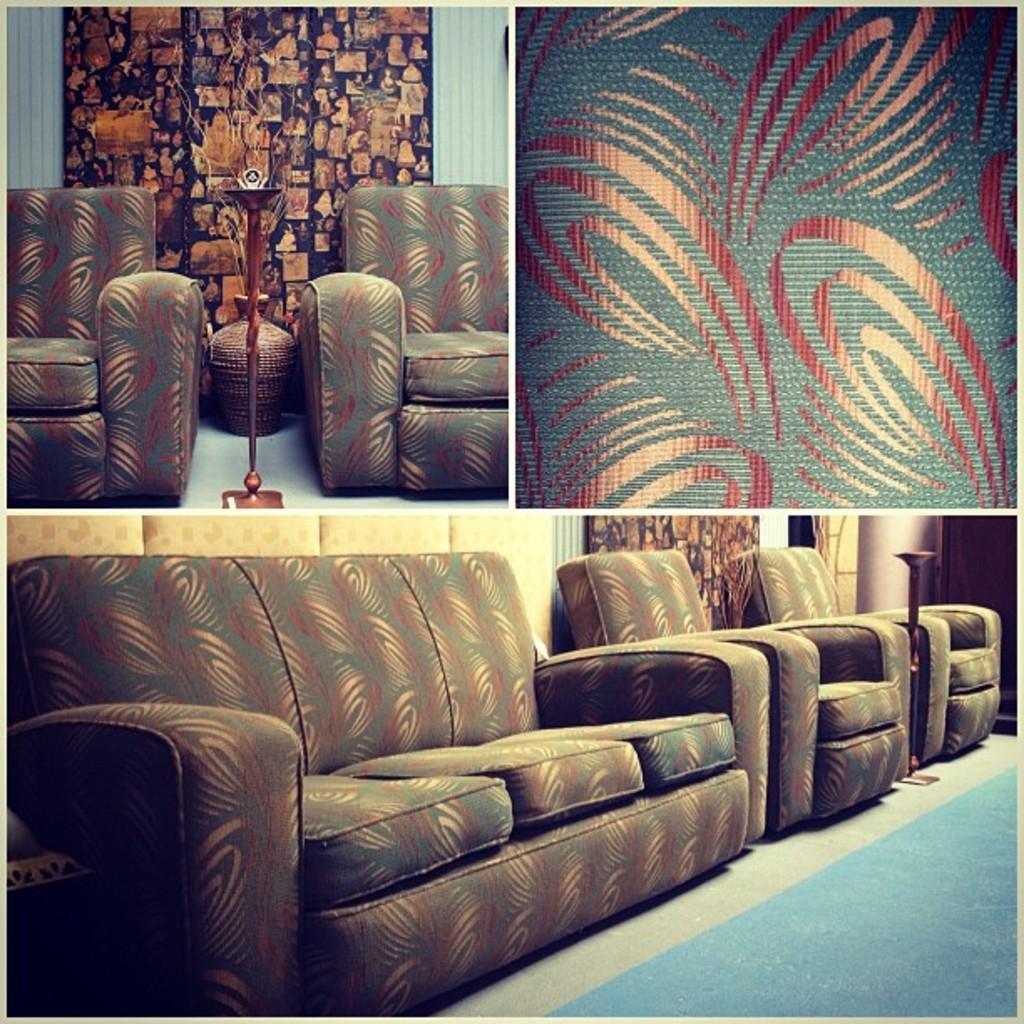Could you give a brief overview of what you see in this image? This is a collage of an image. In the foreground we can see the sofas placed on the ground and a floor carpet. On the top there is a stand and a pot. In the background we can see a wall and a wall art. 